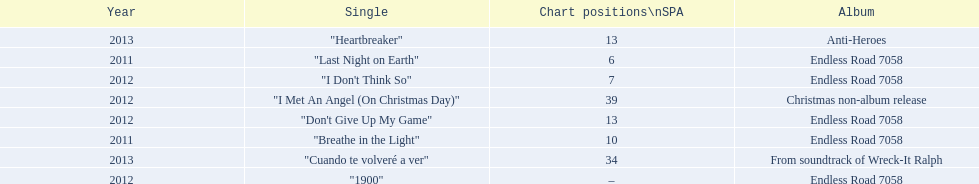Based on sales figures, what auryn album is the most popular? Endless Road 7058. 